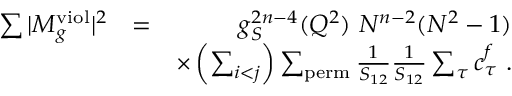<formula> <loc_0><loc_0><loc_500><loc_500>\begin{array} { r l r } { \sum | M _ { g } ^ { v i o l } | ^ { 2 } } & { = } & { g _ { S } ^ { 2 n - 4 } ( Q ^ { 2 } ) N ^ { n - 2 } ( N ^ { 2 } - 1 ) } \\ & { \times \left ( \sum _ { i < j } \right ) \sum _ { p e r m } \frac { 1 } { S _ { 1 2 } } \frac { 1 } { S _ { 1 2 } } \sum _ { \tau } c _ { \tau } ^ { f } . } \end{array}</formula> 